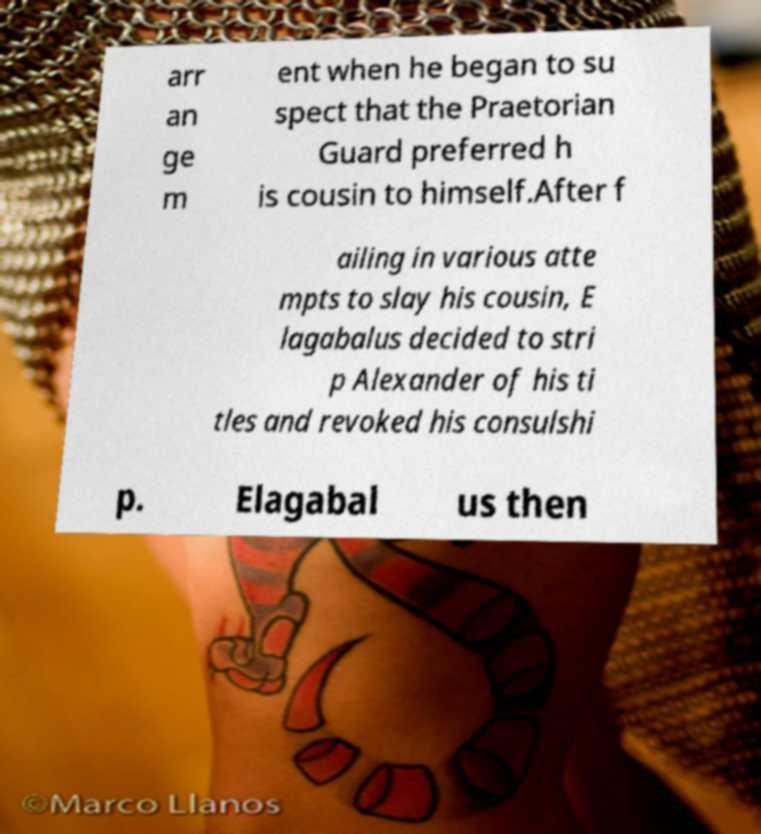Could you extract and type out the text from this image? arr an ge m ent when he began to su spect that the Praetorian Guard preferred h is cousin to himself.After f ailing in various atte mpts to slay his cousin, E lagabalus decided to stri p Alexander of his ti tles and revoked his consulshi p. Elagabal us then 